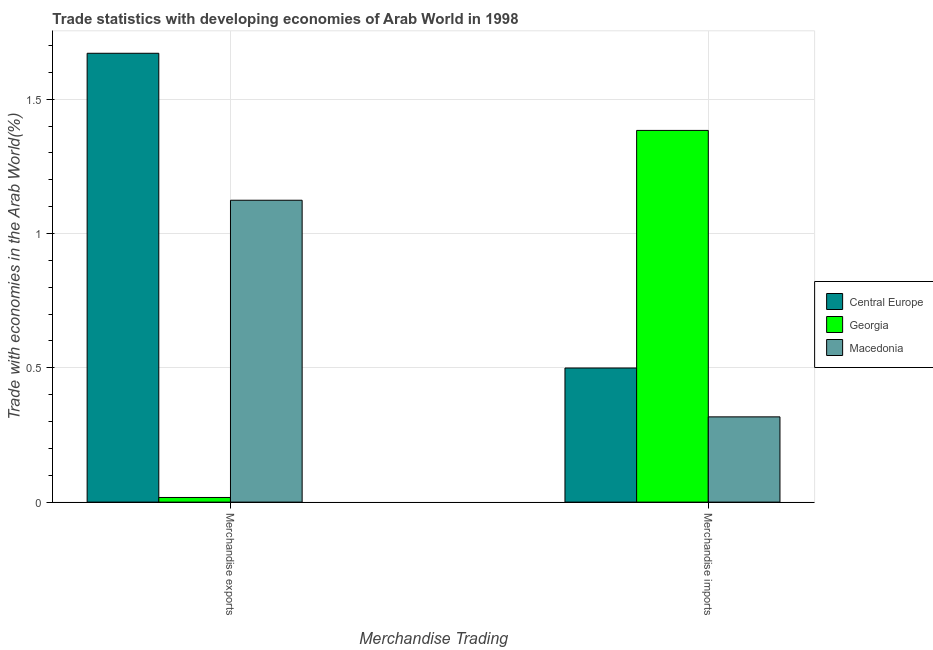How many different coloured bars are there?
Your answer should be compact. 3. How many groups of bars are there?
Keep it short and to the point. 2. How many bars are there on the 1st tick from the left?
Give a very brief answer. 3. What is the label of the 1st group of bars from the left?
Provide a short and direct response. Merchandise exports. What is the merchandise imports in Georgia?
Keep it short and to the point. 1.38. Across all countries, what is the maximum merchandise exports?
Provide a succinct answer. 1.67. Across all countries, what is the minimum merchandise exports?
Your answer should be very brief. 0.02. In which country was the merchandise exports maximum?
Provide a short and direct response. Central Europe. In which country was the merchandise imports minimum?
Ensure brevity in your answer.  Macedonia. What is the total merchandise imports in the graph?
Provide a short and direct response. 2.2. What is the difference between the merchandise imports in Georgia and that in Central Europe?
Your answer should be compact. 0.88. What is the difference between the merchandise imports in Central Europe and the merchandise exports in Macedonia?
Make the answer very short. -0.62. What is the average merchandise imports per country?
Your answer should be compact. 0.73. What is the difference between the merchandise imports and merchandise exports in Macedonia?
Offer a very short reply. -0.81. In how many countries, is the merchandise exports greater than 0.6 %?
Give a very brief answer. 2. What is the ratio of the merchandise exports in Macedonia to that in Central Europe?
Give a very brief answer. 0.67. In how many countries, is the merchandise imports greater than the average merchandise imports taken over all countries?
Offer a terse response. 1. What does the 2nd bar from the left in Merchandise imports represents?
Provide a short and direct response. Georgia. What does the 3rd bar from the right in Merchandise imports represents?
Provide a succinct answer. Central Europe. Are all the bars in the graph horizontal?
Your response must be concise. No. Are the values on the major ticks of Y-axis written in scientific E-notation?
Your answer should be compact. No. Does the graph contain any zero values?
Your answer should be compact. No. How are the legend labels stacked?
Your response must be concise. Vertical. What is the title of the graph?
Ensure brevity in your answer.  Trade statistics with developing economies of Arab World in 1998. Does "Colombia" appear as one of the legend labels in the graph?
Your answer should be very brief. No. What is the label or title of the X-axis?
Make the answer very short. Merchandise Trading. What is the label or title of the Y-axis?
Your answer should be very brief. Trade with economies in the Arab World(%). What is the Trade with economies in the Arab World(%) in Central Europe in Merchandise exports?
Keep it short and to the point. 1.67. What is the Trade with economies in the Arab World(%) of Georgia in Merchandise exports?
Your answer should be very brief. 0.02. What is the Trade with economies in the Arab World(%) in Macedonia in Merchandise exports?
Keep it short and to the point. 1.12. What is the Trade with economies in the Arab World(%) in Central Europe in Merchandise imports?
Your answer should be compact. 0.5. What is the Trade with economies in the Arab World(%) of Georgia in Merchandise imports?
Provide a short and direct response. 1.38. What is the Trade with economies in the Arab World(%) of Macedonia in Merchandise imports?
Your answer should be very brief. 0.32. Across all Merchandise Trading, what is the maximum Trade with economies in the Arab World(%) of Central Europe?
Your response must be concise. 1.67. Across all Merchandise Trading, what is the maximum Trade with economies in the Arab World(%) of Georgia?
Give a very brief answer. 1.38. Across all Merchandise Trading, what is the maximum Trade with economies in the Arab World(%) in Macedonia?
Your response must be concise. 1.12. Across all Merchandise Trading, what is the minimum Trade with economies in the Arab World(%) in Central Europe?
Your answer should be very brief. 0.5. Across all Merchandise Trading, what is the minimum Trade with economies in the Arab World(%) of Georgia?
Your answer should be very brief. 0.02. Across all Merchandise Trading, what is the minimum Trade with economies in the Arab World(%) of Macedonia?
Offer a terse response. 0.32. What is the total Trade with economies in the Arab World(%) in Central Europe in the graph?
Your response must be concise. 2.17. What is the total Trade with economies in the Arab World(%) of Georgia in the graph?
Your answer should be compact. 1.4. What is the total Trade with economies in the Arab World(%) in Macedonia in the graph?
Make the answer very short. 1.44. What is the difference between the Trade with economies in the Arab World(%) in Central Europe in Merchandise exports and that in Merchandise imports?
Give a very brief answer. 1.17. What is the difference between the Trade with economies in the Arab World(%) of Georgia in Merchandise exports and that in Merchandise imports?
Give a very brief answer. -1.37. What is the difference between the Trade with economies in the Arab World(%) in Macedonia in Merchandise exports and that in Merchandise imports?
Make the answer very short. 0.81. What is the difference between the Trade with economies in the Arab World(%) in Central Europe in Merchandise exports and the Trade with economies in the Arab World(%) in Georgia in Merchandise imports?
Your answer should be very brief. 0.29. What is the difference between the Trade with economies in the Arab World(%) in Central Europe in Merchandise exports and the Trade with economies in the Arab World(%) in Macedonia in Merchandise imports?
Ensure brevity in your answer.  1.35. What is the difference between the Trade with economies in the Arab World(%) of Georgia in Merchandise exports and the Trade with economies in the Arab World(%) of Macedonia in Merchandise imports?
Keep it short and to the point. -0.3. What is the average Trade with economies in the Arab World(%) in Central Europe per Merchandise Trading?
Offer a very short reply. 1.08. What is the average Trade with economies in the Arab World(%) in Georgia per Merchandise Trading?
Offer a very short reply. 0.7. What is the average Trade with economies in the Arab World(%) in Macedonia per Merchandise Trading?
Make the answer very short. 0.72. What is the difference between the Trade with economies in the Arab World(%) in Central Europe and Trade with economies in the Arab World(%) in Georgia in Merchandise exports?
Your answer should be very brief. 1.65. What is the difference between the Trade with economies in the Arab World(%) of Central Europe and Trade with economies in the Arab World(%) of Macedonia in Merchandise exports?
Ensure brevity in your answer.  0.55. What is the difference between the Trade with economies in the Arab World(%) of Georgia and Trade with economies in the Arab World(%) of Macedonia in Merchandise exports?
Make the answer very short. -1.11. What is the difference between the Trade with economies in the Arab World(%) in Central Europe and Trade with economies in the Arab World(%) in Georgia in Merchandise imports?
Your response must be concise. -0.88. What is the difference between the Trade with economies in the Arab World(%) in Central Europe and Trade with economies in the Arab World(%) in Macedonia in Merchandise imports?
Ensure brevity in your answer.  0.18. What is the difference between the Trade with economies in the Arab World(%) in Georgia and Trade with economies in the Arab World(%) in Macedonia in Merchandise imports?
Keep it short and to the point. 1.07. What is the ratio of the Trade with economies in the Arab World(%) of Central Europe in Merchandise exports to that in Merchandise imports?
Your answer should be compact. 3.35. What is the ratio of the Trade with economies in the Arab World(%) in Georgia in Merchandise exports to that in Merchandise imports?
Give a very brief answer. 0.01. What is the ratio of the Trade with economies in the Arab World(%) in Macedonia in Merchandise exports to that in Merchandise imports?
Your response must be concise. 3.54. What is the difference between the highest and the second highest Trade with economies in the Arab World(%) in Central Europe?
Provide a succinct answer. 1.17. What is the difference between the highest and the second highest Trade with economies in the Arab World(%) in Georgia?
Keep it short and to the point. 1.37. What is the difference between the highest and the second highest Trade with economies in the Arab World(%) in Macedonia?
Keep it short and to the point. 0.81. What is the difference between the highest and the lowest Trade with economies in the Arab World(%) in Central Europe?
Make the answer very short. 1.17. What is the difference between the highest and the lowest Trade with economies in the Arab World(%) in Georgia?
Ensure brevity in your answer.  1.37. What is the difference between the highest and the lowest Trade with economies in the Arab World(%) of Macedonia?
Your response must be concise. 0.81. 